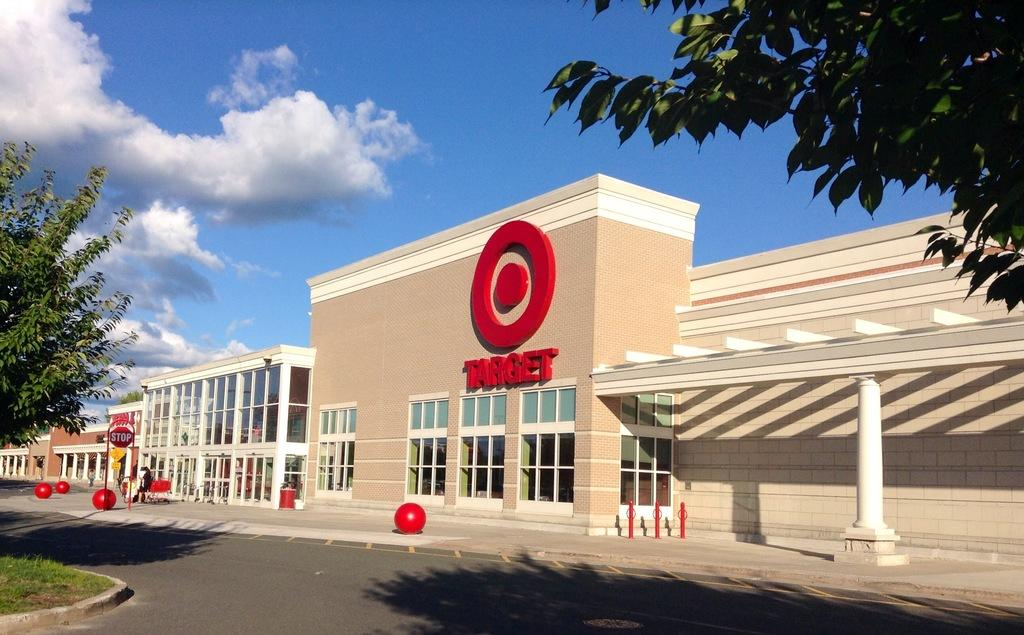How many persons are visible in the image? There are persons in the image, but the exact number is not specified. What objects are present in the image along with the persons? There are balls visible in the image. What can be seen in front of a building in the image? There is a sign board in front of a building in the image. What type of natural elements are present in the image? There are trees and clouds visible in the image. What type of page is being turned in the image? There is no page present in the image, so it is not possible to determine if any page is being turned. 